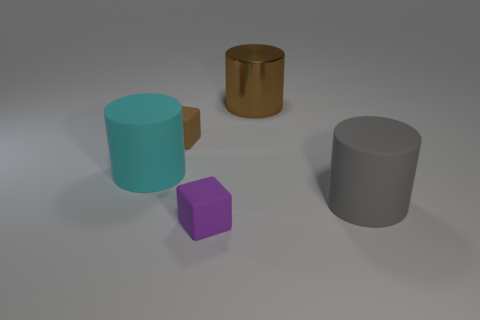The purple object that is the same material as the large cyan object is what shape?
Offer a terse response. Cube. Is the thing that is in front of the gray object made of the same material as the brown block?
Ensure brevity in your answer.  Yes. What number of other things are made of the same material as the big brown cylinder?
Give a very brief answer. 0. How many things are either big objects in front of the big cyan matte cylinder or small matte things in front of the tiny brown thing?
Ensure brevity in your answer.  2. There is a object in front of the big gray matte cylinder; is its shape the same as the small thing that is behind the big gray thing?
Your response must be concise. Yes. What is the shape of the other rubber thing that is the same size as the brown rubber object?
Offer a terse response. Cube. What number of rubber objects are cyan cylinders or gray objects?
Keep it short and to the point. 2. Are the cube behind the big gray cylinder and the cylinder that is on the right side of the large brown object made of the same material?
Ensure brevity in your answer.  Yes. The other large cylinder that is made of the same material as the gray cylinder is what color?
Provide a short and direct response. Cyan. Are there more matte objects to the left of the large metallic cylinder than cyan things behind the brown rubber cube?
Give a very brief answer. Yes. 